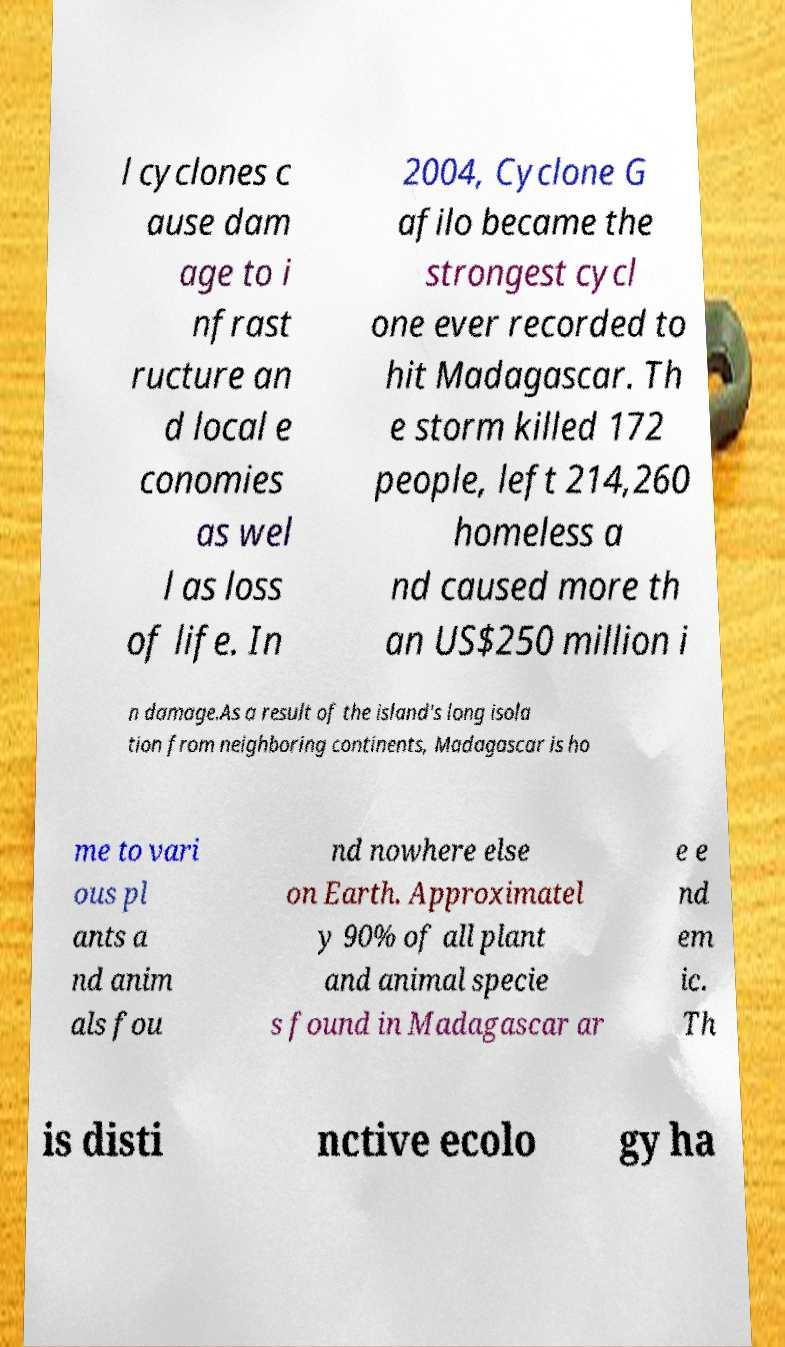Can you accurately transcribe the text from the provided image for me? l cyclones c ause dam age to i nfrast ructure an d local e conomies as wel l as loss of life. In 2004, Cyclone G afilo became the strongest cycl one ever recorded to hit Madagascar. Th e storm killed 172 people, left 214,260 homeless a nd caused more th an US$250 million i n damage.As a result of the island's long isola tion from neighboring continents, Madagascar is ho me to vari ous pl ants a nd anim als fou nd nowhere else on Earth. Approximatel y 90% of all plant and animal specie s found in Madagascar ar e e nd em ic. Th is disti nctive ecolo gy ha 